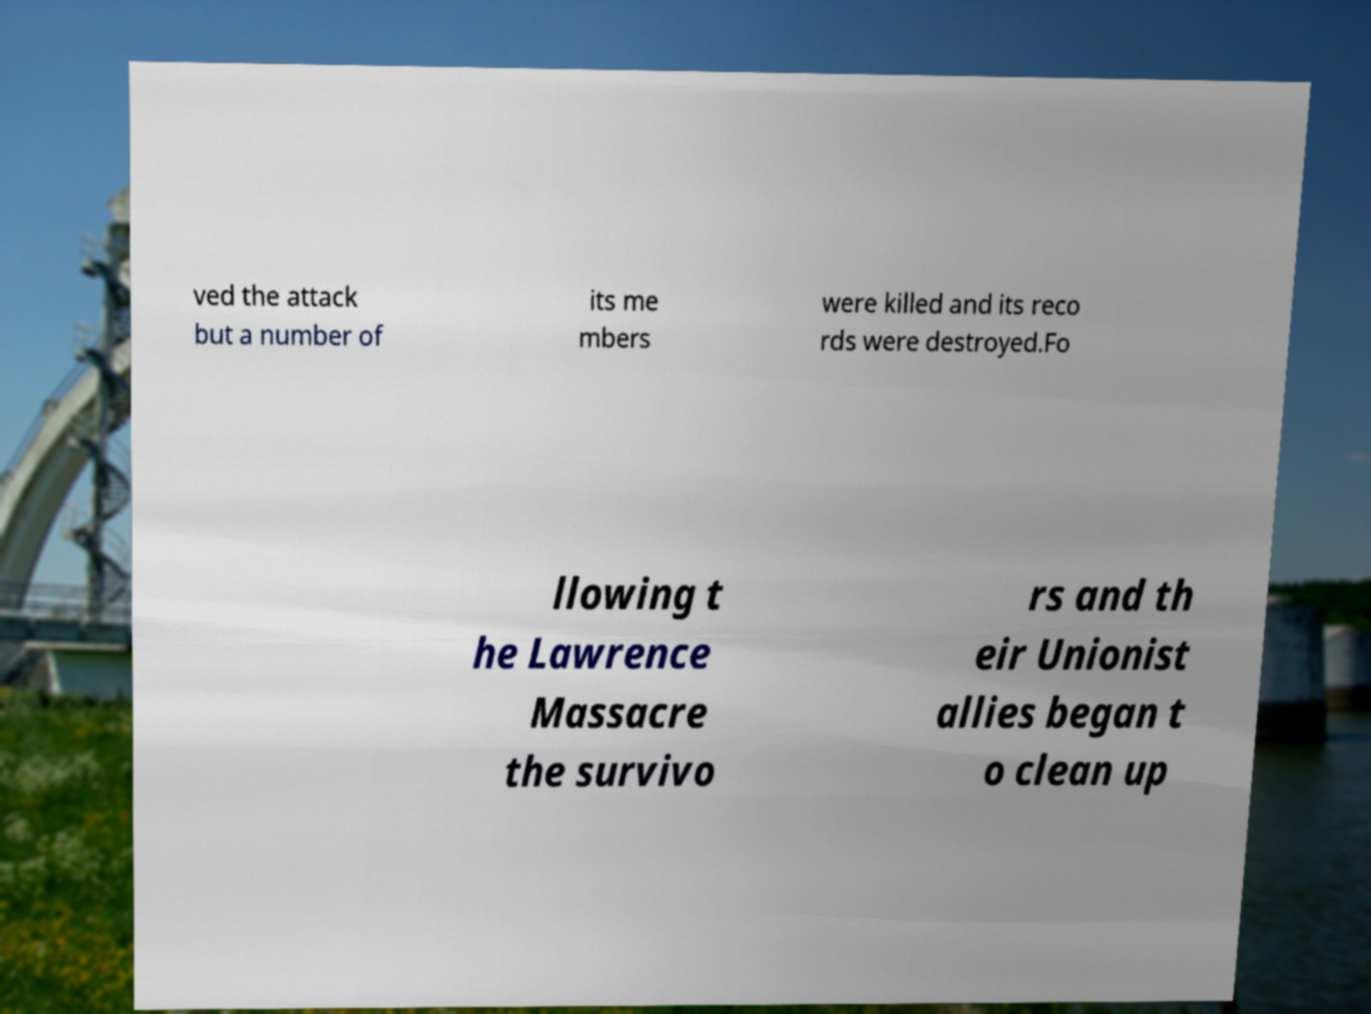Could you assist in decoding the text presented in this image and type it out clearly? ved the attack but a number of its me mbers were killed and its reco rds were destroyed.Fo llowing t he Lawrence Massacre the survivo rs and th eir Unionist allies began t o clean up 